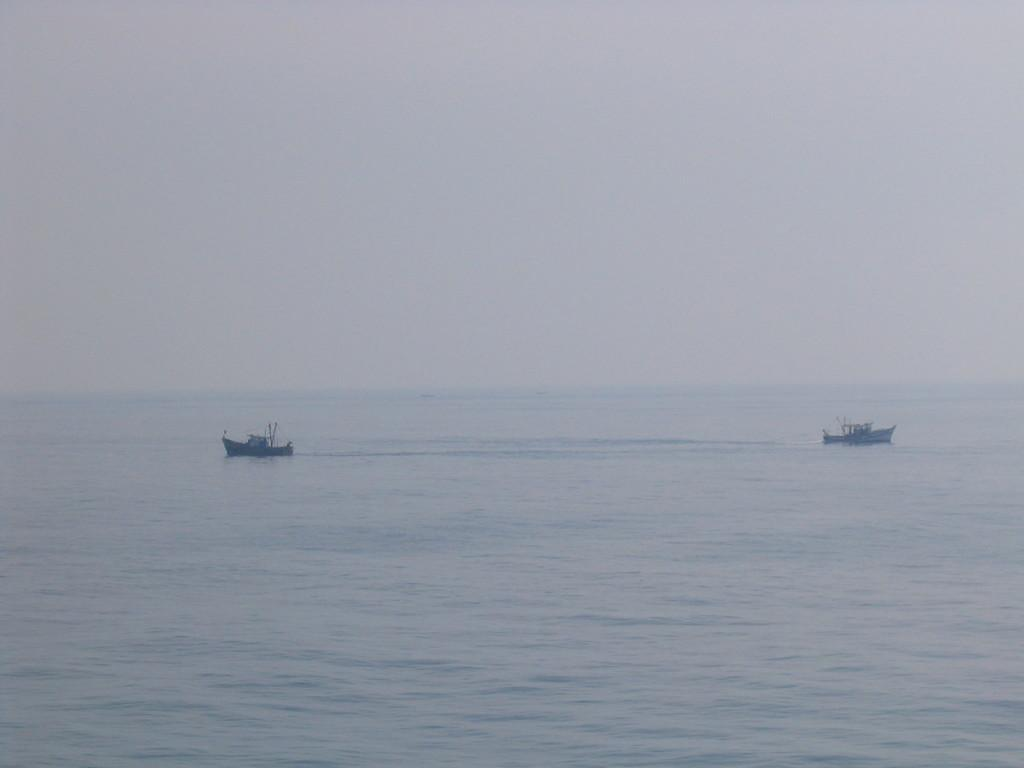What can be seen on the water body in the image? There are two boats on a water body in the image. What is the condition of the sky in the image? The sky is clear in the image. What type of fiction is being read by the cub in the image? There is no cub or fiction present in the image; it features two boats on a water body with a clear sky. 